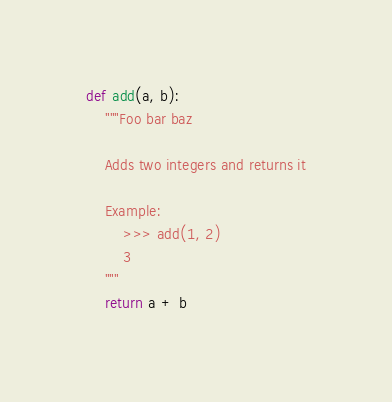<code> <loc_0><loc_0><loc_500><loc_500><_Python_>def add(a, b):
    """Foo bar baz
    
    Adds two integers and returns it

    Example:
        >>> add(1, 2)
        3
    """
    return a + b

</code> 